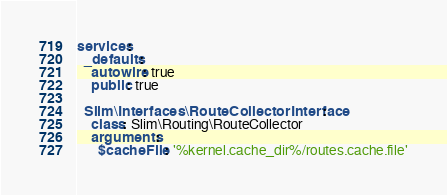<code> <loc_0><loc_0><loc_500><loc_500><_YAML_>services:
  _defaults:
    autowire: true
    public: true

  Slim\Interfaces\RouteCollectorInterface:
    class: Slim\Routing\RouteCollector
    arguments:
      $cacheFile: '%kernel.cache_dir%/routes.cache.file'</code> 